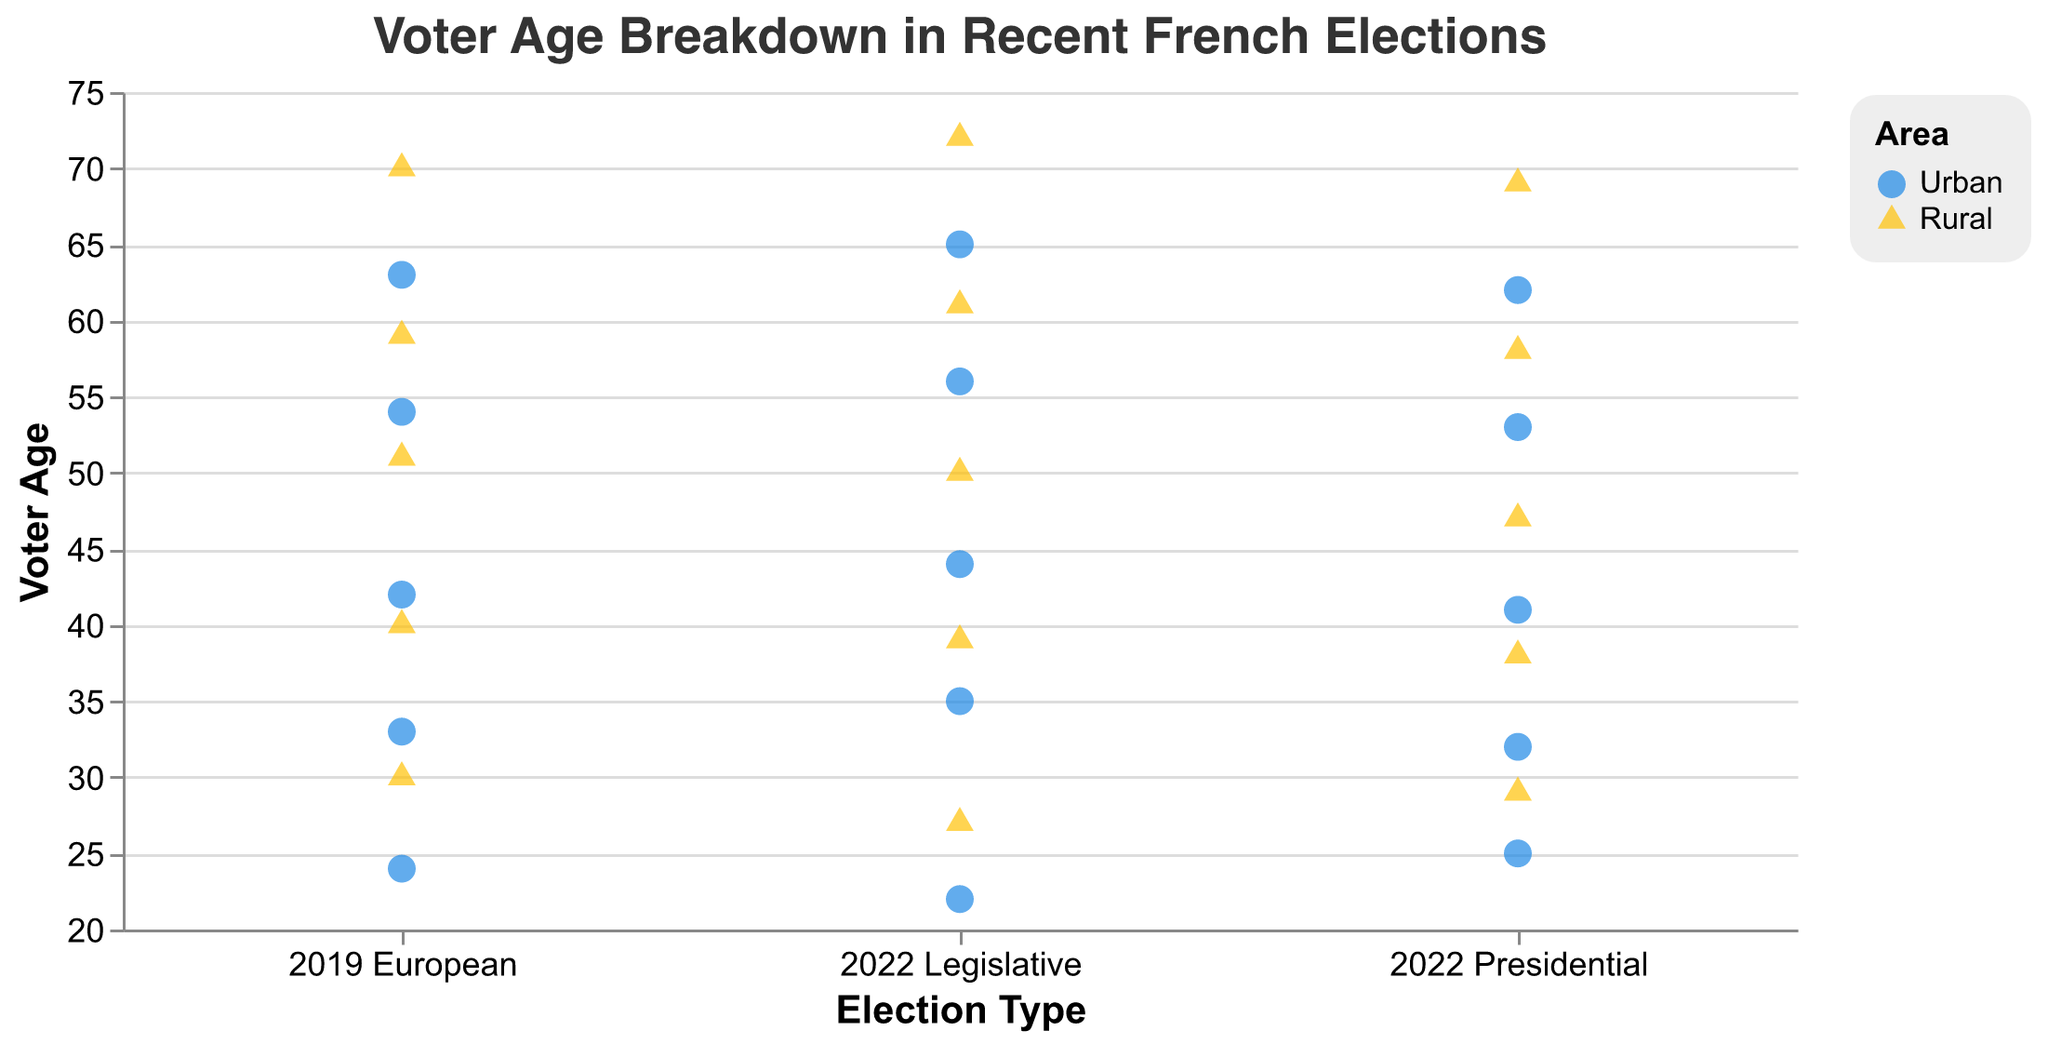What is the title of the figure? The title of the figure is displayed at the top center. It reads "Voter Age Breakdown in Recent French Elections".
Answer: Voter Age Breakdown in Recent French Elections What areas are represented by different colors in the plot? The legend at the right side of the plot shows that "Urban" areas are represented by blue color and "Rural" areas are represented by yellow color.
Answer: Urban is blue, Rural is yellow How many elections are represented in the plot? The x-axis of the plot lists three different categories for elections: "2022 Presidential", "2022 Legislative", and "2019 European".
Answer: 3 Which election type has the widest range of voter ages in rural areas? Looking at the range of yellow triangle points (rural areas) along the y-axis, the "2022 Legislative" election has the widest range, with ages spanning from 27 to 72.
Answer: 2022 Legislative What is the age of the oldest urban voter in the 2019 European election? By observing the blue circle points (urban areas) under the "2019 European" category, the highest y-value is 63.
Answer: 63 How does the median age of voters in rural areas for the 2022 Legislative election compare to the 2022 Presidential election? For the "2022 Legislative" election, rural voter ages are 27, 39, 50, 61, and 72. For the "2022 Presidential" election, rural voter ages are 29, 38, 47, 58, and 69. Calculating the medians, both are 50.
Answer: They are the same Which area has a higher maximum age for the 2022 Presidential election? Comparing the highest points for blue circles (urban) and yellow triangles (rural) under "2022 Presidential", the maximum ages are 62 and 69 respectively.
Answer: Rural What is the difference in the youngest voter age between urban and rural areas for the 2022 Legislative election? The youngest urban voter in the "2022 Legislative" election is 22, while the youngest rural voter is 27. The difference is 5.
Answer: 5 How many urban voters are there for each election type? Counting the blue circles for each election type: "2022 Presidential" has 5, "2022 Legislative" has 5, and "2019 European" has 5.
Answer: Each election type has 5 Compare the voter age distributions between urban and rural areas for the 2019 European election. Considering the y-values of points under the "2019 European" category, urban voters range from 24 to 63, while rural voters range from 30 to 70. Both distributions appear to cover a sizable range, but the rural area has a slightly higher maximum age.
Answer: Urban: 24-63, Rural: 30-70 